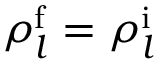Convert formula to latex. <formula><loc_0><loc_0><loc_500><loc_500>\rho _ { l } ^ { \mathrm f } = \rho _ { l } ^ { \mathrm i }</formula> 